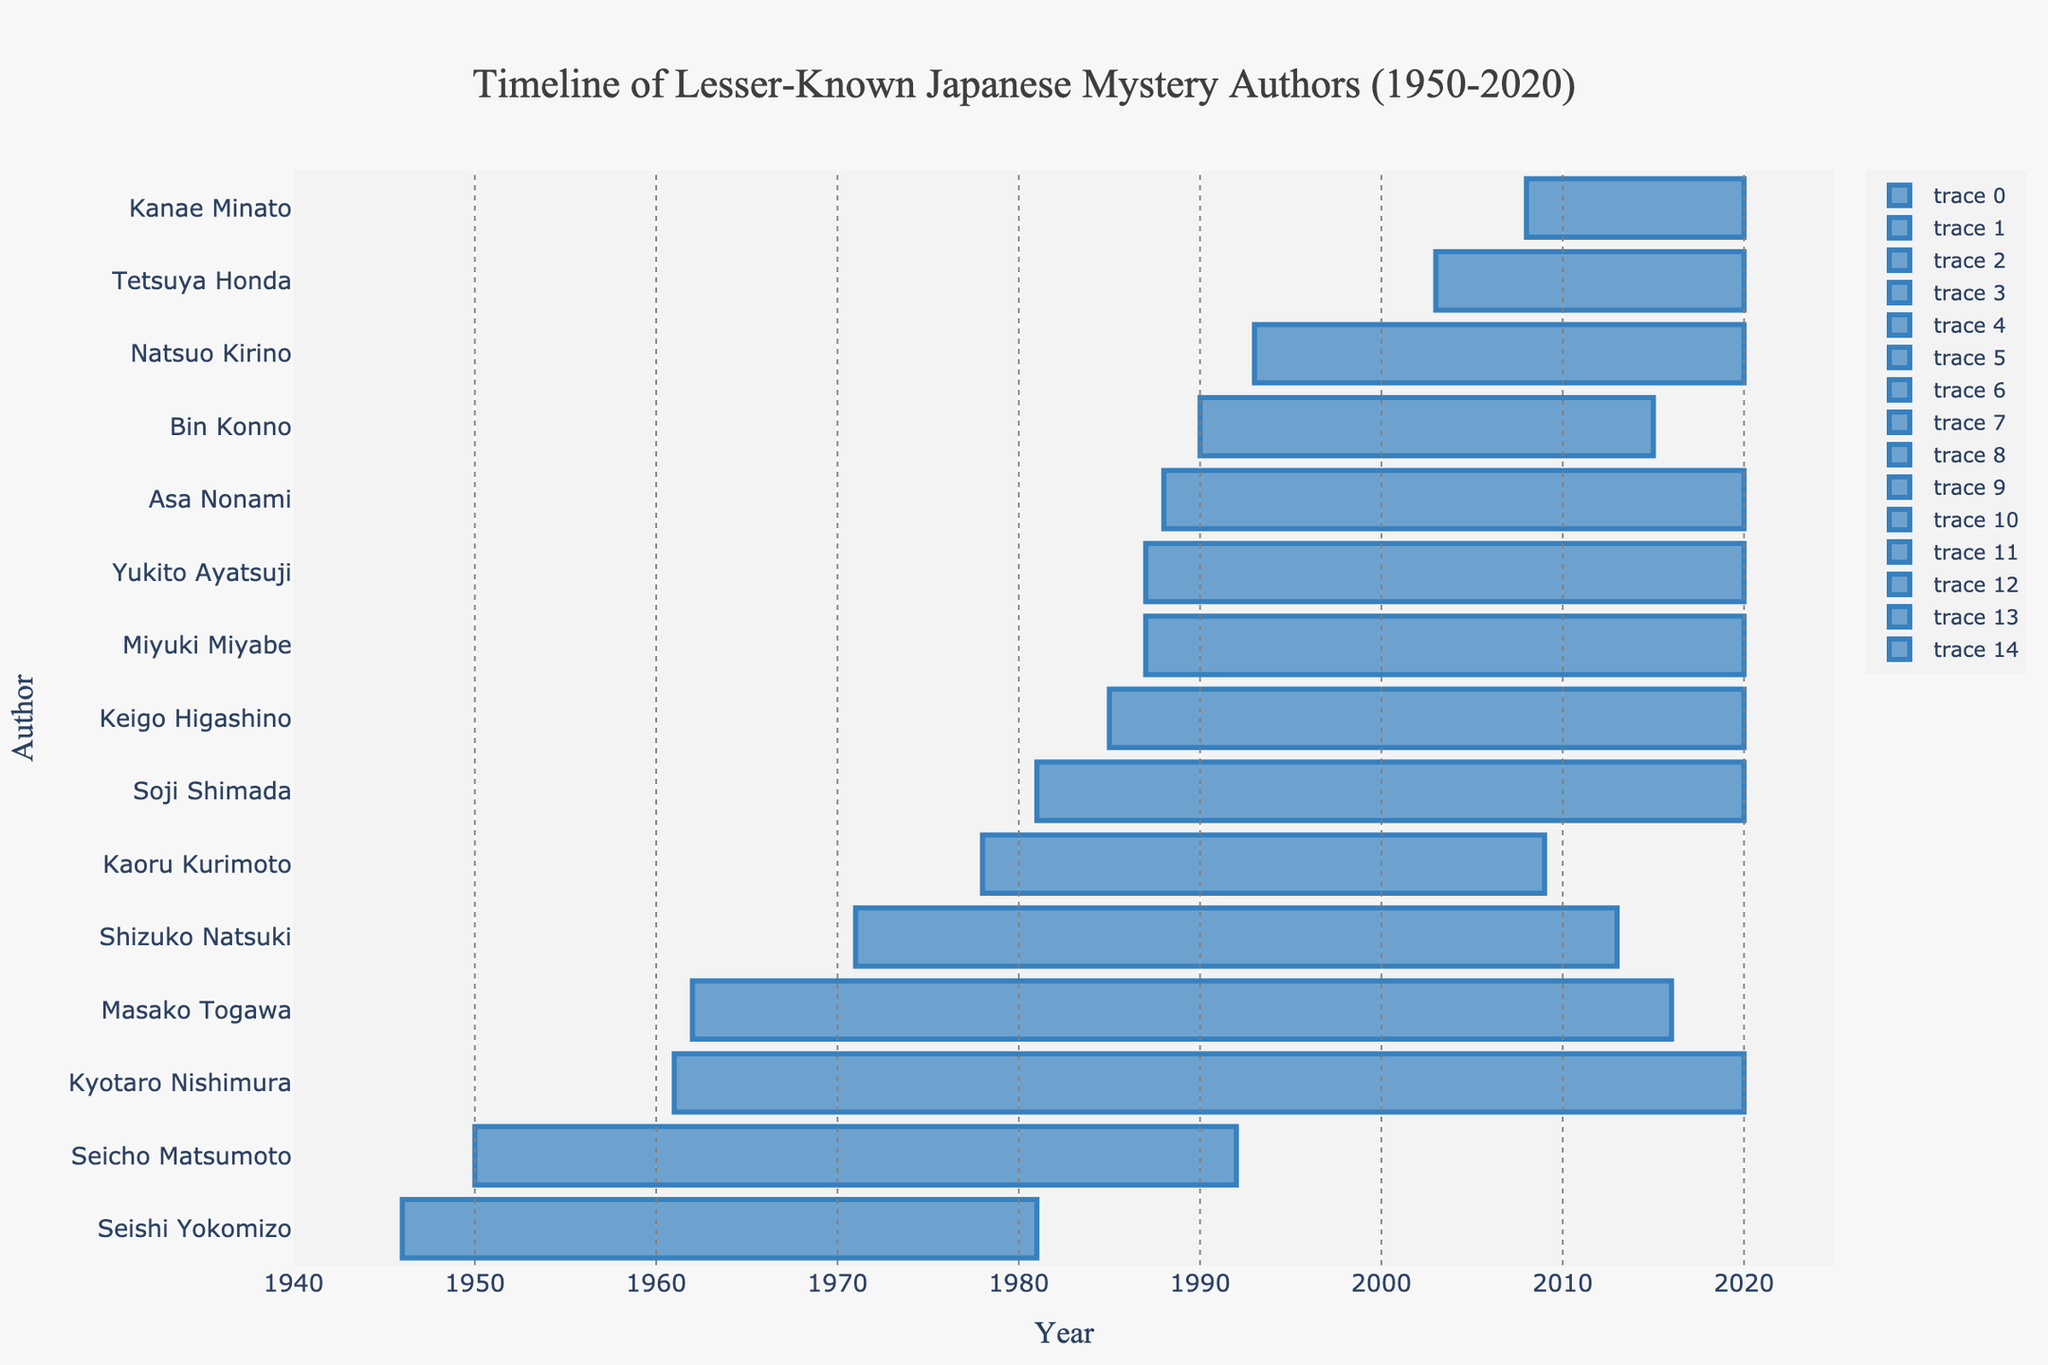Which author has the longest publication period? To determine the author with the longest publication period, look for the author whose bar extends the most from the starting year to the ending year. Kyotaro Nishimura's bar spans from 1961 to 2020.
Answer: Kyotaro Nishimura Who started publishing first among these authors? Observe the bar for the author whose bar starts at the earliest position on the x-axis. Seishi Yokomizo's bar starts at 1946.
Answer: Seishi Yokomizo How many authors were actively publishing in the 1990s? Count the number of bars that intersect with the 1990-2000 range on the x-axis.
Answer: 10 Which two authors have the most overlapping publication periods starting from the same year? Look for authors with bars that start in the same year and compare the overlap in their publication periods. Miyuki Miyabe and Yukito Ayatsuji both started in 1987 and continue through 2020.
Answer: Miyuki Miyabe and Yukito Ayatsuji What is the average publication period of all the authors? Calculate the average of all individual publication durations. Sum each author's duration (years) and divide by the number of authors. (46 + 43 + 54 + 42 + 31 + 27 + 35 + 33 + 39 + 32 + 25 + 17 + 12 + 13 + 35)/15 = 33.27 years
Answer: 33 years Which author ended their publication period the earliest? Locate the bar with the earliest end year on the x-axis. Seishi Yokomizo's bar ends at 1981.
Answer: Seishi Yokomizo Who began their publishing career in 1987? Identify the author(s) whose bar starts on the year 1987. Miyuki Miyabe and Yukito Ayatsuji's bars both start at 1987.
Answer: Miyuki Miyabe and Yukito Ayatsuji Did any authors have overlapping publication periods that completely fall within another author’s timeline? Look for bars (time periods) that are entirely within the start and end year of another author's bar. Bin Konno's publication period (1990-2015) falls entirely within Kaoru Kurimoto's period (1978-2009).
Answer: Bin Konno within Kaoru Kurimoto How many authors have bars extending beyond the year 2000? Count the number of authors whose bars extend past the year 2000 on the x-axis.
Answer: 10 